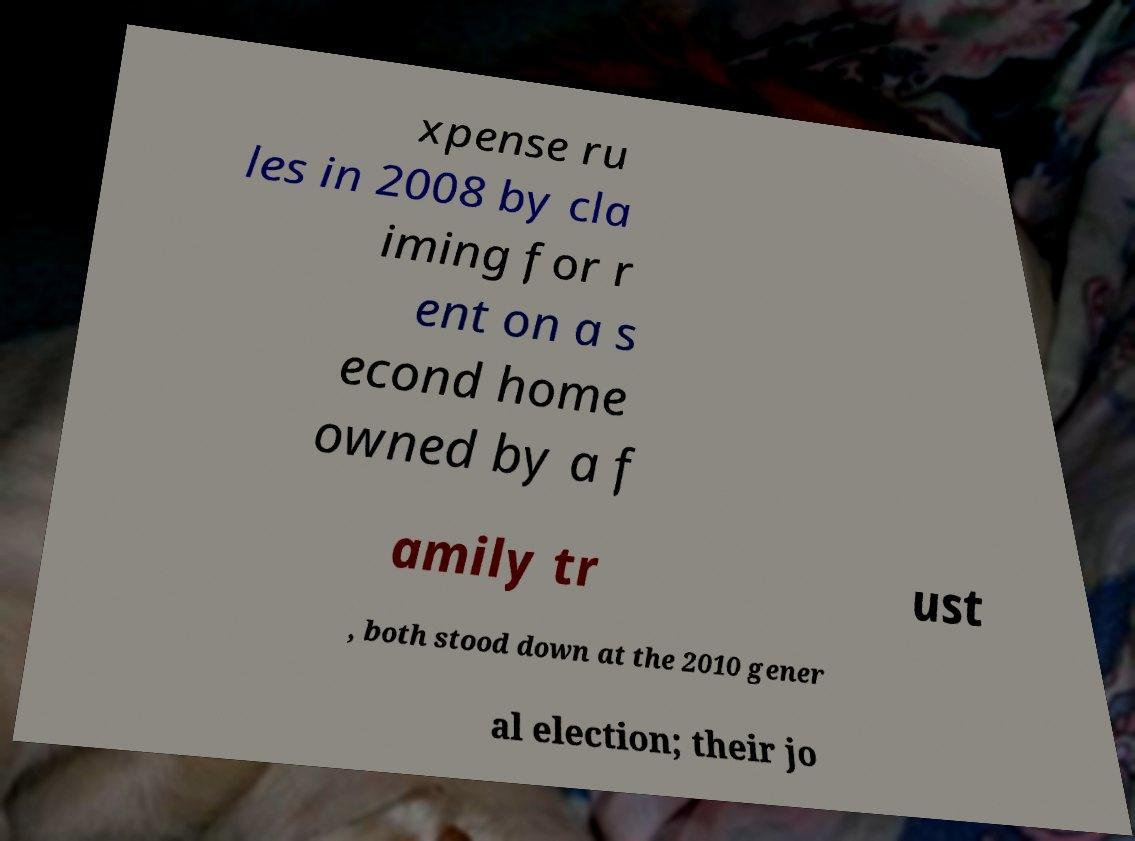I need the written content from this picture converted into text. Can you do that? xpense ru les in 2008 by cla iming for r ent on a s econd home owned by a f amily tr ust , both stood down at the 2010 gener al election; their jo 